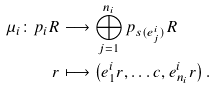<formula> <loc_0><loc_0><loc_500><loc_500>\mu _ { i } \colon p _ { i } R & \longrightarrow \bigoplus _ { j = 1 } ^ { n _ { i } } p _ { s ( e ^ { i } _ { j } ) } R \\ r & \longmapsto \left ( e ^ { i } _ { 1 } r , \dots c , e ^ { i } _ { n _ { i } } r \right ) .</formula> 